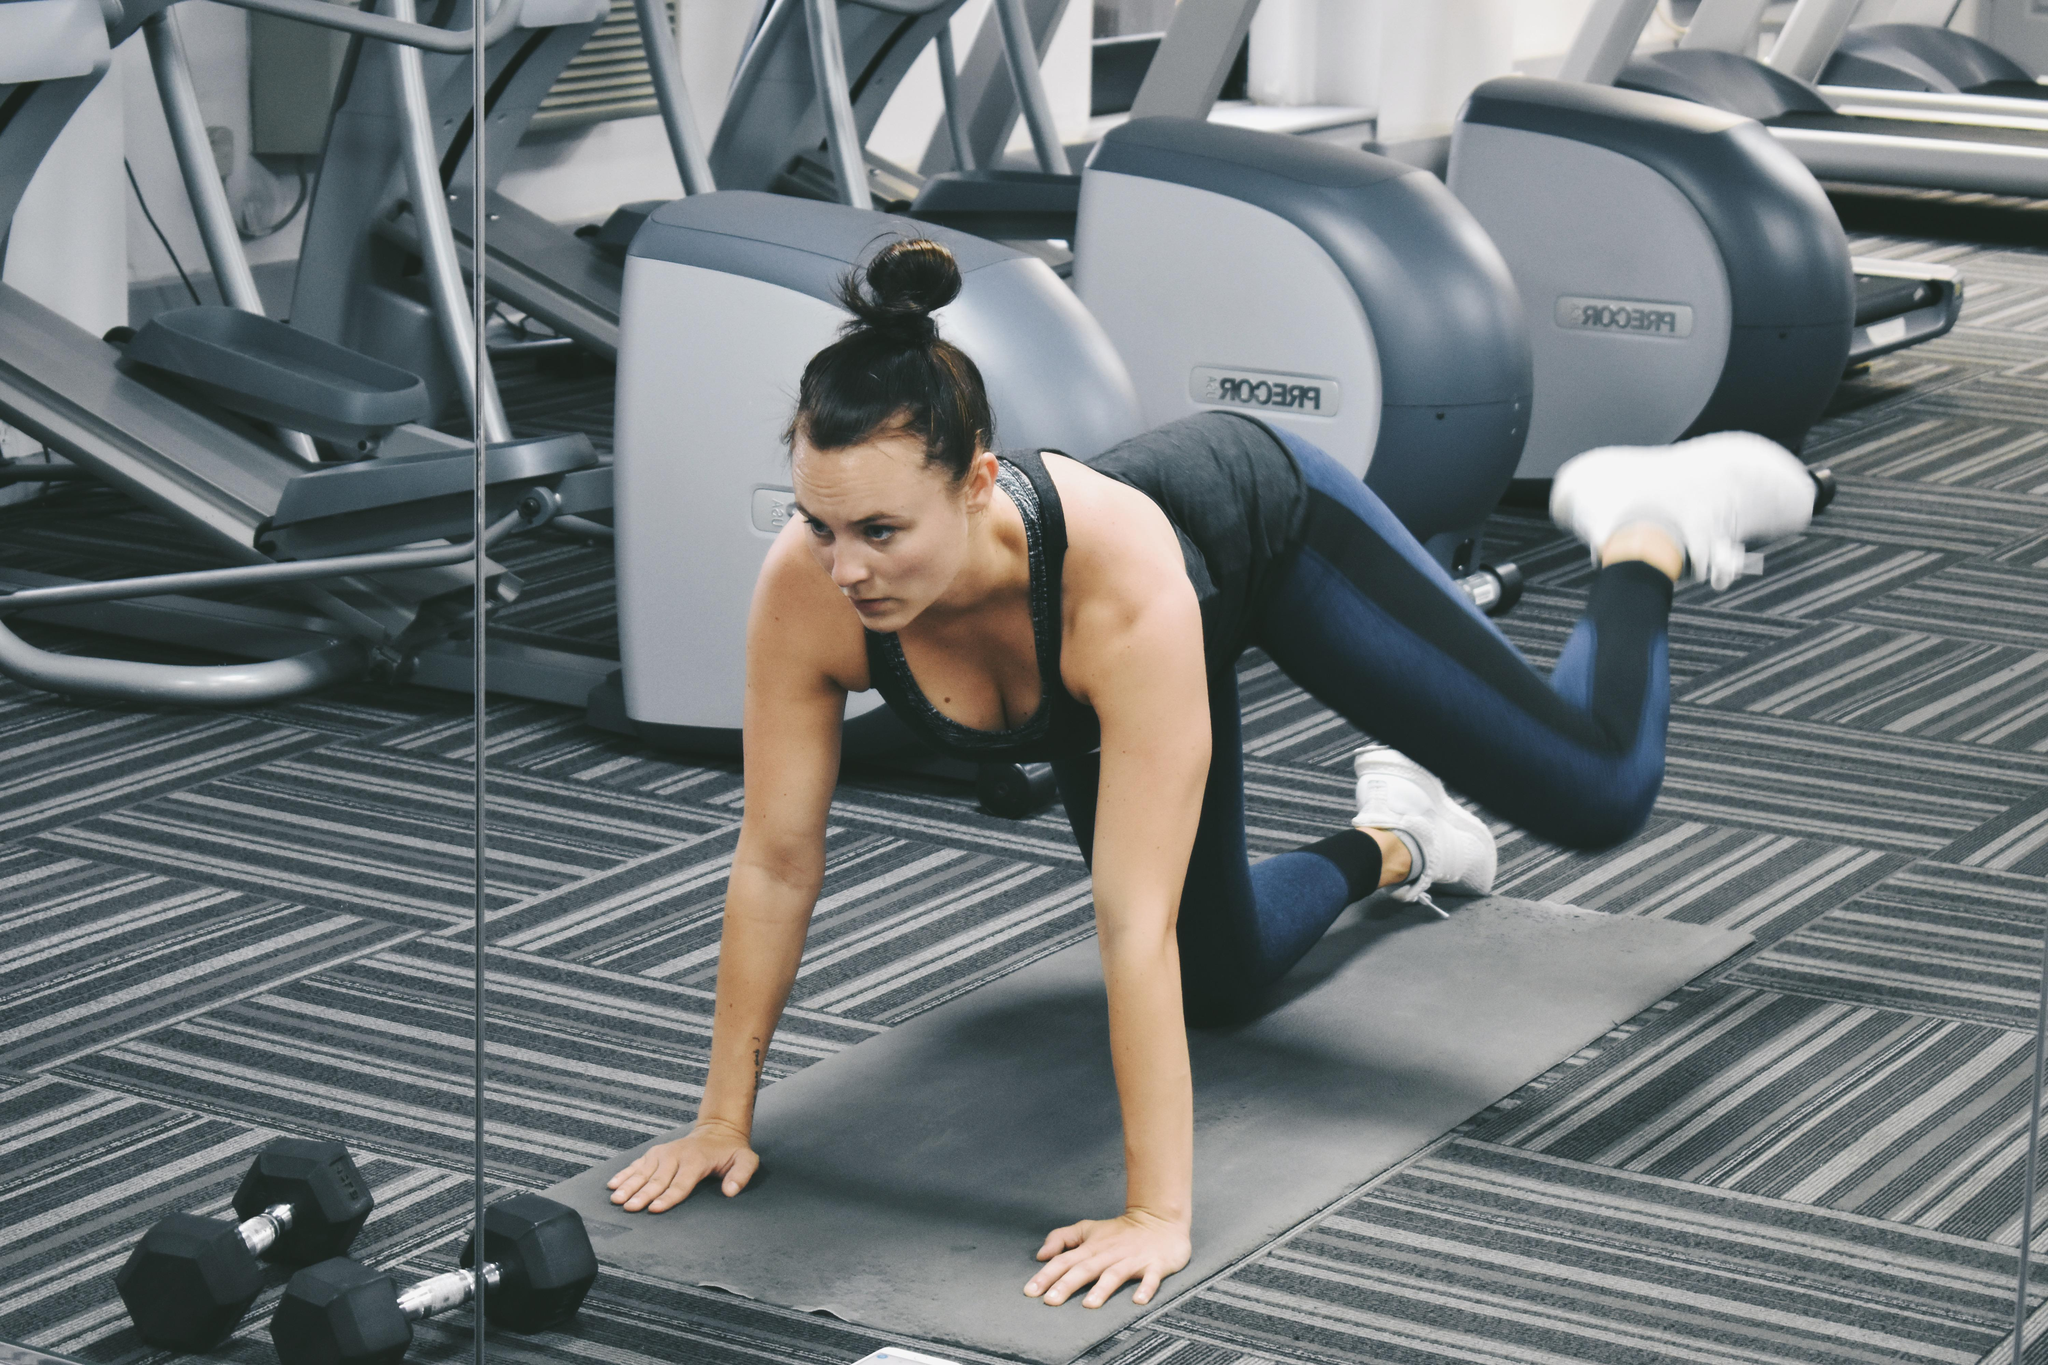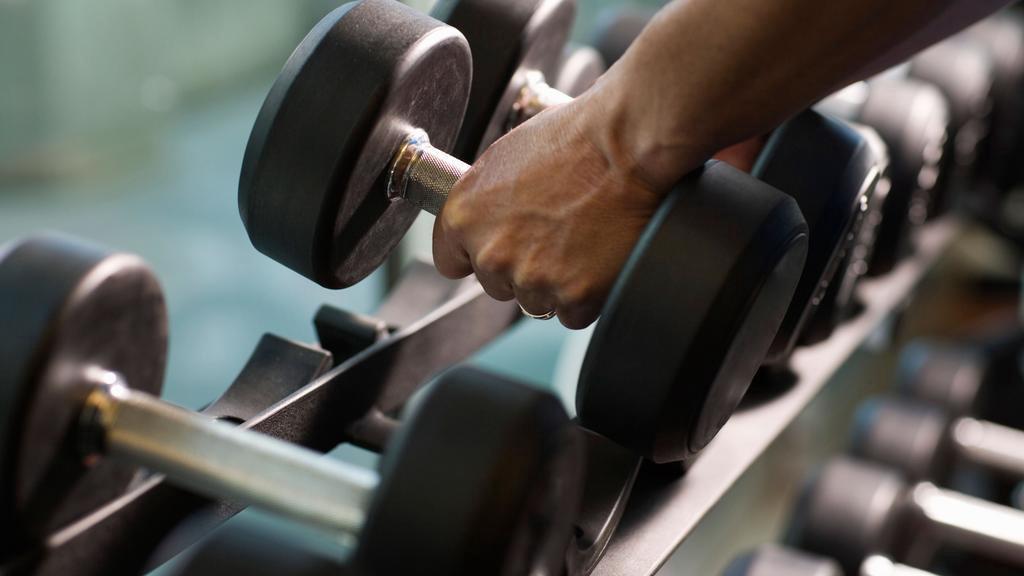The first image is the image on the left, the second image is the image on the right. Analyze the images presented: Is the assertion "At least one of the images has a man." valid? Answer yes or no. No. The first image is the image on the left, the second image is the image on the right. Considering the images on both sides, is "The left and right image contains  a total of four people working out." valid? Answer yes or no. No. 